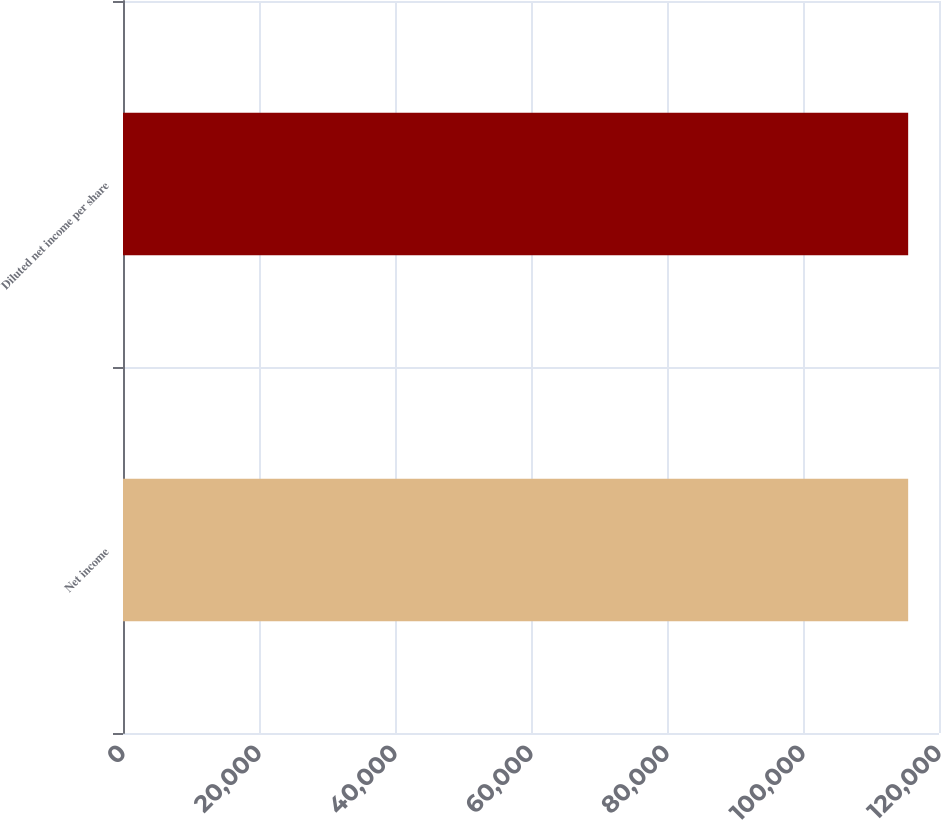<chart> <loc_0><loc_0><loc_500><loc_500><bar_chart><fcel>Net income<fcel>Diluted net income per share<nl><fcel>115466<fcel>115466<nl></chart> 